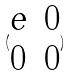Convert formula to latex. <formula><loc_0><loc_0><loc_500><loc_500>( \begin{matrix} e & 0 \\ 0 & 0 \end{matrix} )</formula> 